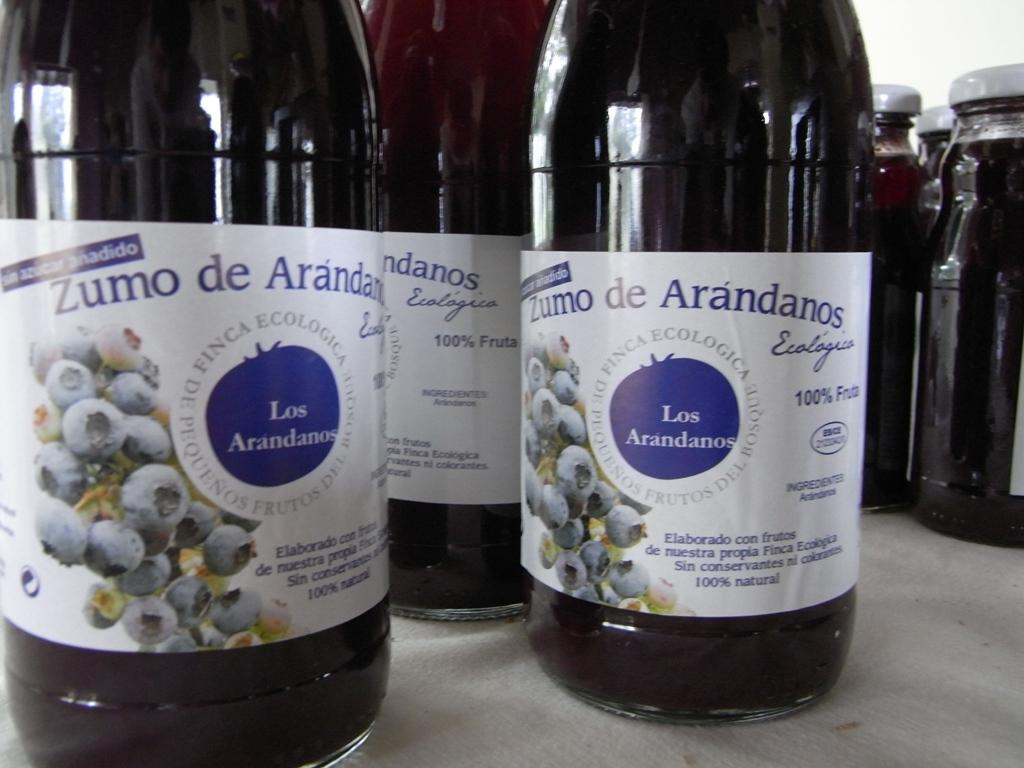<image>
Create a compact narrative representing the image presented. bottle of zumo de arandanos on the counter 